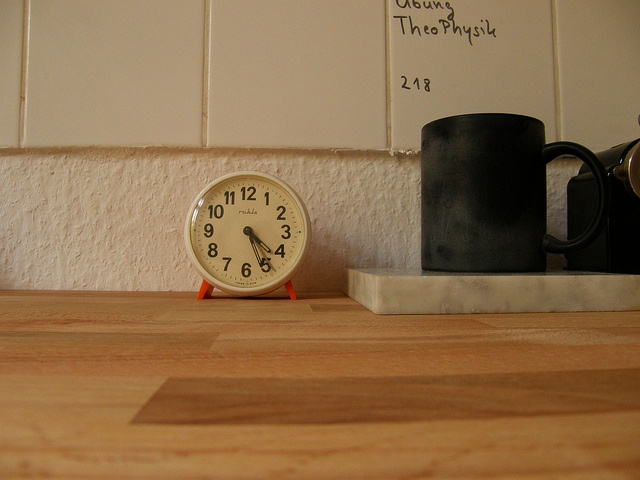Describe the objects in this image and their specific colors. I can see cup in olive, black, and gray tones and clock in olive and tan tones in this image. 